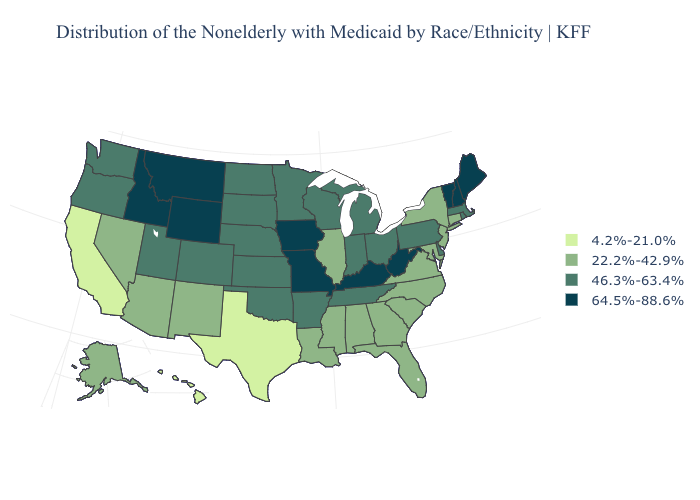Does Texas have the same value as Pennsylvania?
Quick response, please. No. Is the legend a continuous bar?
Give a very brief answer. No. Does South Dakota have the same value as Iowa?
Be succinct. No. Which states hav the highest value in the West?
Write a very short answer. Idaho, Montana, Wyoming. Among the states that border West Virginia , which have the lowest value?
Be succinct. Maryland, Virginia. Name the states that have a value in the range 64.5%-88.6%?
Answer briefly. Idaho, Iowa, Kentucky, Maine, Missouri, Montana, New Hampshire, Vermont, West Virginia, Wyoming. Does the first symbol in the legend represent the smallest category?
Answer briefly. Yes. Does Texas have the highest value in the USA?
Give a very brief answer. No. What is the lowest value in the USA?
Write a very short answer. 4.2%-21.0%. Which states hav the highest value in the West?
Quick response, please. Idaho, Montana, Wyoming. Among the states that border California , which have the highest value?
Answer briefly. Oregon. Does the map have missing data?
Write a very short answer. No. What is the value of South Carolina?
Keep it brief. 22.2%-42.9%. What is the value of Tennessee?
Short answer required. 46.3%-63.4%. 